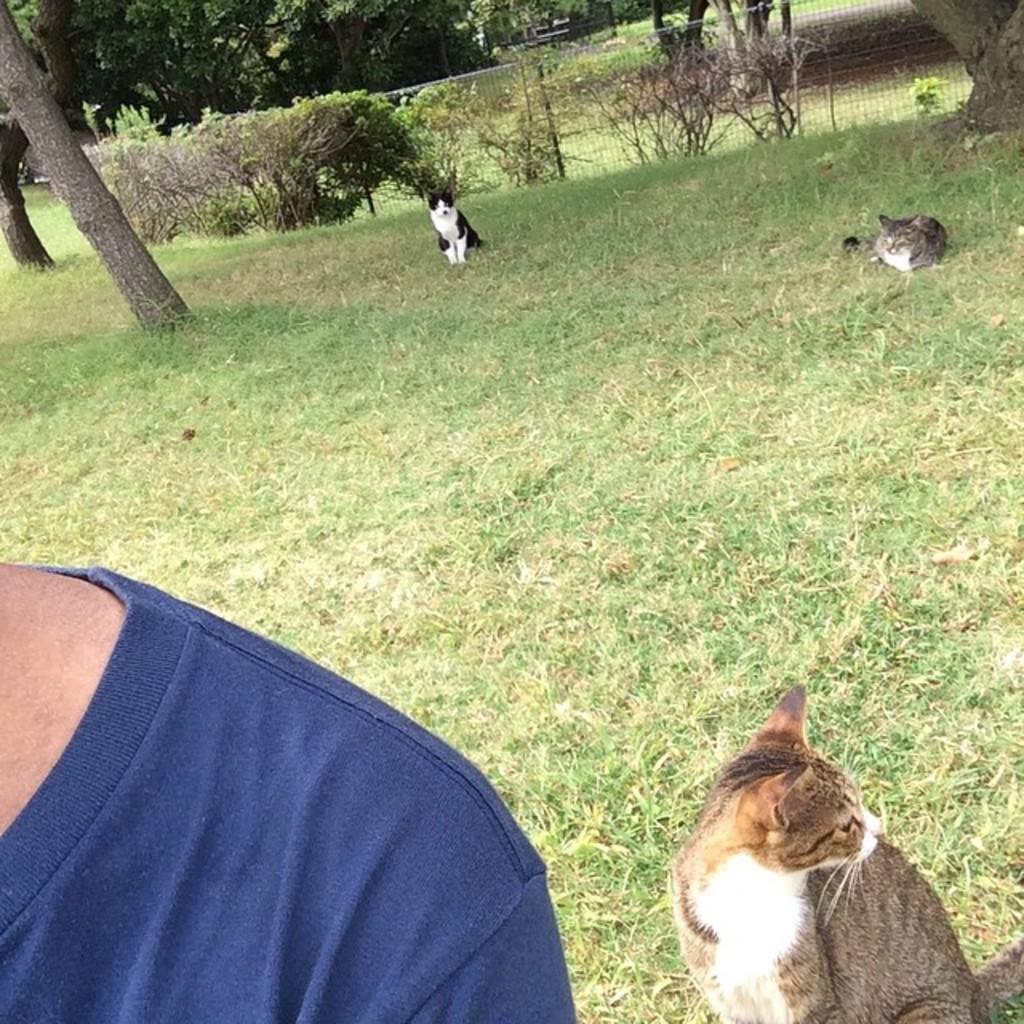How would you summarize this image in a sentence or two? In this image we can see a person, few animals on the ground, trees and fence in the background. 